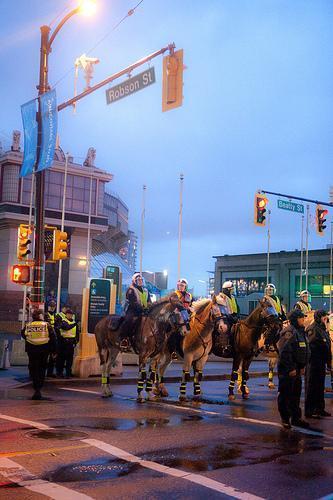How many police officers are standing on the ground?
Give a very brief answer. 6. 